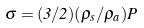<formula> <loc_0><loc_0><loc_500><loc_500>\sigma = ( 3 / 2 ) ( \rho _ { s } / \rho _ { a } ) P</formula> 